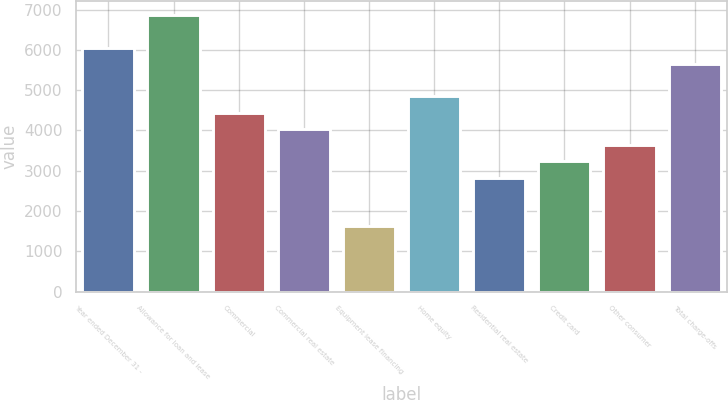Convert chart to OTSL. <chart><loc_0><loc_0><loc_500><loc_500><bar_chart><fcel>Year ended December 31 -<fcel>Allowance for loan and lease<fcel>Commercial<fcel>Commercial real estate<fcel>Equipment lease financing<fcel>Home equity<fcel>Residential real estate<fcel>Credit card<fcel>Other consumer<fcel>Total charge-offs<nl><fcel>6053.67<fcel>6860.75<fcel>4439.51<fcel>4035.97<fcel>1614.73<fcel>4843.05<fcel>2825.35<fcel>3228.89<fcel>3632.43<fcel>5650.13<nl></chart> 